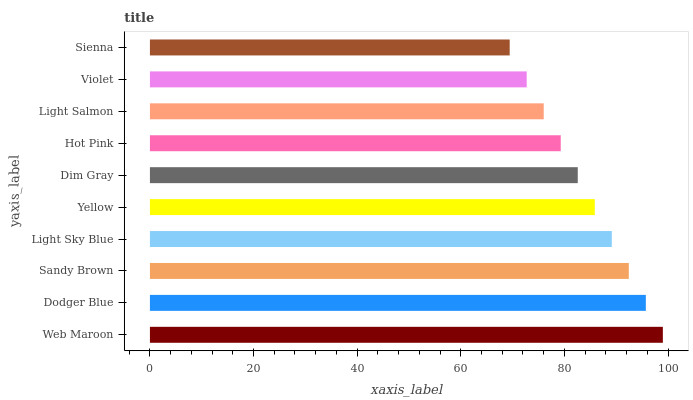Is Sienna the minimum?
Answer yes or no. Yes. Is Web Maroon the maximum?
Answer yes or no. Yes. Is Dodger Blue the minimum?
Answer yes or no. No. Is Dodger Blue the maximum?
Answer yes or no. No. Is Web Maroon greater than Dodger Blue?
Answer yes or no. Yes. Is Dodger Blue less than Web Maroon?
Answer yes or no. Yes. Is Dodger Blue greater than Web Maroon?
Answer yes or no. No. Is Web Maroon less than Dodger Blue?
Answer yes or no. No. Is Yellow the high median?
Answer yes or no. Yes. Is Dim Gray the low median?
Answer yes or no. Yes. Is Hot Pink the high median?
Answer yes or no. No. Is Web Maroon the low median?
Answer yes or no. No. 